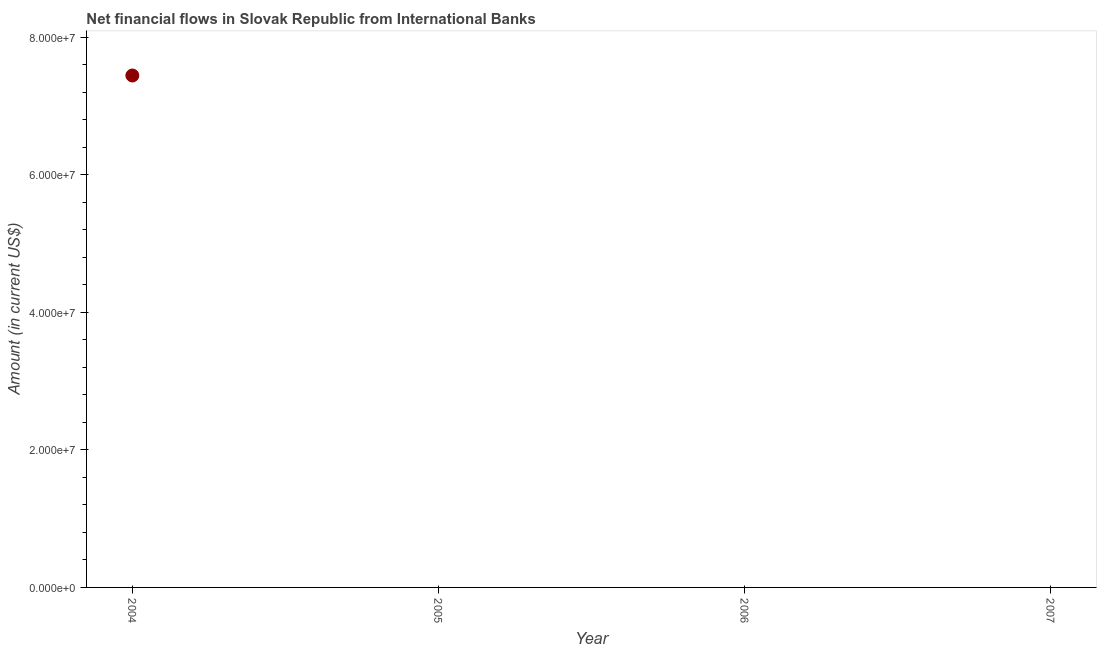What is the net financial flows from ibrd in 2004?
Your response must be concise. 7.44e+07. Across all years, what is the maximum net financial flows from ibrd?
Your answer should be compact. 7.44e+07. Across all years, what is the minimum net financial flows from ibrd?
Keep it short and to the point. 0. What is the sum of the net financial flows from ibrd?
Ensure brevity in your answer.  7.44e+07. What is the average net financial flows from ibrd per year?
Offer a very short reply. 1.86e+07. In how many years, is the net financial flows from ibrd greater than 60000000 US$?
Offer a very short reply. 1. What is the difference between the highest and the lowest net financial flows from ibrd?
Provide a short and direct response. 7.44e+07. How many years are there in the graph?
Your answer should be very brief. 4. Are the values on the major ticks of Y-axis written in scientific E-notation?
Make the answer very short. Yes. Does the graph contain any zero values?
Your answer should be very brief. Yes. What is the title of the graph?
Your answer should be compact. Net financial flows in Slovak Republic from International Banks. What is the label or title of the X-axis?
Provide a short and direct response. Year. What is the label or title of the Y-axis?
Ensure brevity in your answer.  Amount (in current US$). What is the Amount (in current US$) in 2004?
Your response must be concise. 7.44e+07. What is the Amount (in current US$) in 2006?
Ensure brevity in your answer.  0. 